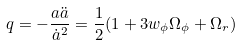<formula> <loc_0><loc_0><loc_500><loc_500>q = - \frac { a \ddot { a } } { \dot { a } ^ { 2 } } = \frac { 1 } { 2 } ( 1 + 3 w _ { \phi } \Omega _ { \phi } + \Omega _ { r } )</formula> 